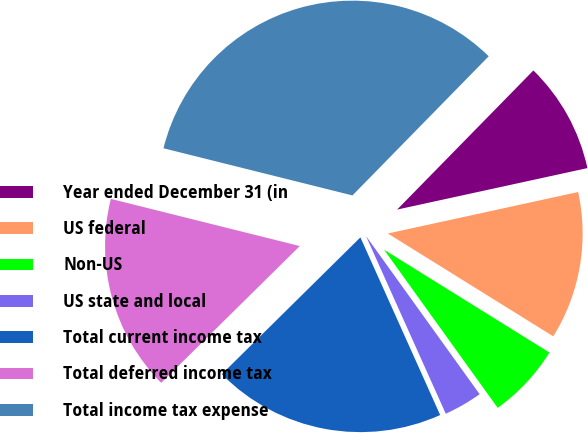<chart> <loc_0><loc_0><loc_500><loc_500><pie_chart><fcel>Year ended December 31 (in<fcel>US federal<fcel>Non-US<fcel>US state and local<fcel>Total current income tax<fcel>Total deferred income tax<fcel>Total income tax expense<nl><fcel>9.25%<fcel>12.27%<fcel>6.23%<fcel>3.2%<fcel>19.32%<fcel>16.29%<fcel>33.44%<nl></chart> 